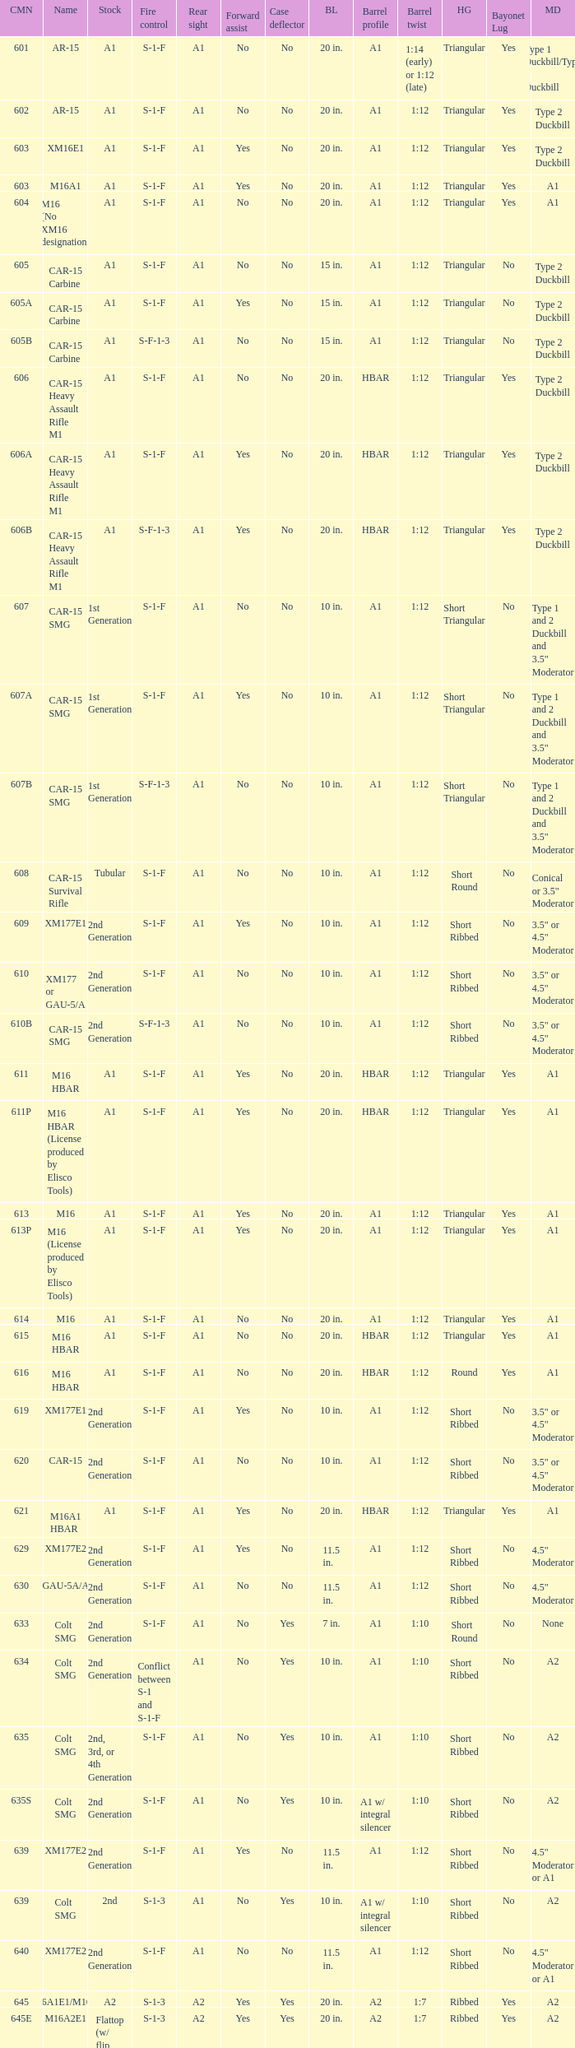What's the type of muzzle devices on the models with round hand guards? A1. Could you help me parse every detail presented in this table? {'header': ['CMN', 'Name', 'Stock', 'Fire control', 'Rear sight', 'Forward assist', 'Case deflector', 'BL', 'Barrel profile', 'Barrel twist', 'HG', 'Bayonet Lug', 'MD'], 'rows': [['601', 'AR-15', 'A1', 'S-1-F', 'A1', 'No', 'No', '20 in.', 'A1', '1:14 (early) or 1:12 (late)', 'Triangular', 'Yes', 'Type 1 Duckbill/Type 2 Duckbill'], ['602', 'AR-15', 'A1', 'S-1-F', 'A1', 'No', 'No', '20 in.', 'A1', '1:12', 'Triangular', 'Yes', 'Type 2 Duckbill'], ['603', 'XM16E1', 'A1', 'S-1-F', 'A1', 'Yes', 'No', '20 in.', 'A1', '1:12', 'Triangular', 'Yes', 'Type 2 Duckbill'], ['603', 'M16A1', 'A1', 'S-1-F', 'A1', 'Yes', 'No', '20 in.', 'A1', '1:12', 'Triangular', 'Yes', 'A1'], ['604', 'M16 (No XM16 designation)', 'A1', 'S-1-F', 'A1', 'No', 'No', '20 in.', 'A1', '1:12', 'Triangular', 'Yes', 'A1'], ['605', 'CAR-15 Carbine', 'A1', 'S-1-F', 'A1', 'No', 'No', '15 in.', 'A1', '1:12', 'Triangular', 'No', 'Type 2 Duckbill'], ['605A', 'CAR-15 Carbine', 'A1', 'S-1-F', 'A1', 'Yes', 'No', '15 in.', 'A1', '1:12', 'Triangular', 'No', 'Type 2 Duckbill'], ['605B', 'CAR-15 Carbine', 'A1', 'S-F-1-3', 'A1', 'No', 'No', '15 in.', 'A1', '1:12', 'Triangular', 'No', 'Type 2 Duckbill'], ['606', 'CAR-15 Heavy Assault Rifle M1', 'A1', 'S-1-F', 'A1', 'No', 'No', '20 in.', 'HBAR', '1:12', 'Triangular', 'Yes', 'Type 2 Duckbill'], ['606A', 'CAR-15 Heavy Assault Rifle M1', 'A1', 'S-1-F', 'A1', 'Yes', 'No', '20 in.', 'HBAR', '1:12', 'Triangular', 'Yes', 'Type 2 Duckbill'], ['606B', 'CAR-15 Heavy Assault Rifle M1', 'A1', 'S-F-1-3', 'A1', 'Yes', 'No', '20 in.', 'HBAR', '1:12', 'Triangular', 'Yes', 'Type 2 Duckbill'], ['607', 'CAR-15 SMG', '1st Generation', 'S-1-F', 'A1', 'No', 'No', '10 in.', 'A1', '1:12', 'Short Triangular', 'No', 'Type 1 and 2 Duckbill and 3.5" Moderator'], ['607A', 'CAR-15 SMG', '1st Generation', 'S-1-F', 'A1', 'Yes', 'No', '10 in.', 'A1', '1:12', 'Short Triangular', 'No', 'Type 1 and 2 Duckbill and 3.5" Moderator'], ['607B', 'CAR-15 SMG', '1st Generation', 'S-F-1-3', 'A1', 'No', 'No', '10 in.', 'A1', '1:12', 'Short Triangular', 'No', 'Type 1 and 2 Duckbill and 3.5" Moderator'], ['608', 'CAR-15 Survival Rifle', 'Tubular', 'S-1-F', 'A1', 'No', 'No', '10 in.', 'A1', '1:12', 'Short Round', 'No', 'Conical or 3.5" Moderator'], ['609', 'XM177E1', '2nd Generation', 'S-1-F', 'A1', 'Yes', 'No', '10 in.', 'A1', '1:12', 'Short Ribbed', 'No', '3.5" or 4.5" Moderator'], ['610', 'XM177 or GAU-5/A', '2nd Generation', 'S-1-F', 'A1', 'No', 'No', '10 in.', 'A1', '1:12', 'Short Ribbed', 'No', '3.5" or 4.5" Moderator'], ['610B', 'CAR-15 SMG', '2nd Generation', 'S-F-1-3', 'A1', 'No', 'No', '10 in.', 'A1', '1:12', 'Short Ribbed', 'No', '3.5" or 4.5" Moderator'], ['611', 'M16 HBAR', 'A1', 'S-1-F', 'A1', 'Yes', 'No', '20 in.', 'HBAR', '1:12', 'Triangular', 'Yes', 'A1'], ['611P', 'M16 HBAR (License produced by Elisco Tools)', 'A1', 'S-1-F', 'A1', 'Yes', 'No', '20 in.', 'HBAR', '1:12', 'Triangular', 'Yes', 'A1'], ['613', 'M16', 'A1', 'S-1-F', 'A1', 'Yes', 'No', '20 in.', 'A1', '1:12', 'Triangular', 'Yes', 'A1'], ['613P', 'M16 (License produced by Elisco Tools)', 'A1', 'S-1-F', 'A1', 'Yes', 'No', '20 in.', 'A1', '1:12', 'Triangular', 'Yes', 'A1'], ['614', 'M16', 'A1', 'S-1-F', 'A1', 'No', 'No', '20 in.', 'A1', '1:12', 'Triangular', 'Yes', 'A1'], ['615', 'M16 HBAR', 'A1', 'S-1-F', 'A1', 'No', 'No', '20 in.', 'HBAR', '1:12', 'Triangular', 'Yes', 'A1'], ['616', 'M16 HBAR', 'A1', 'S-1-F', 'A1', 'No', 'No', '20 in.', 'HBAR', '1:12', 'Round', 'Yes', 'A1'], ['619', 'XM177E1', '2nd Generation', 'S-1-F', 'A1', 'Yes', 'No', '10 in.', 'A1', '1:12', 'Short Ribbed', 'No', '3.5" or 4.5" Moderator'], ['620', 'CAR-15', '2nd Generation', 'S-1-F', 'A1', 'No', 'No', '10 in.', 'A1', '1:12', 'Short Ribbed', 'No', '3.5" or 4.5" Moderator'], ['621', 'M16A1 HBAR', 'A1', 'S-1-F', 'A1', 'Yes', 'No', '20 in.', 'HBAR', '1:12', 'Triangular', 'Yes', 'A1'], ['629', 'XM177E2', '2nd Generation', 'S-1-F', 'A1', 'Yes', 'No', '11.5 in.', 'A1', '1:12', 'Short Ribbed', 'No', '4.5" Moderator'], ['630', 'GAU-5A/A', '2nd Generation', 'S-1-F', 'A1', 'No', 'No', '11.5 in.', 'A1', '1:12', 'Short Ribbed', 'No', '4.5" Moderator'], ['633', 'Colt SMG', '2nd Generation', 'S-1-F', 'A1', 'No', 'Yes', '7 in.', 'A1', '1:10', 'Short Round', 'No', 'None'], ['634', 'Colt SMG', '2nd Generation', 'Conflict between S-1 and S-1-F', 'A1', 'No', 'Yes', '10 in.', 'A1', '1:10', 'Short Ribbed', 'No', 'A2'], ['635', 'Colt SMG', '2nd, 3rd, or 4th Generation', 'S-1-F', 'A1', 'No', 'Yes', '10 in.', 'A1', '1:10', 'Short Ribbed', 'No', 'A2'], ['635S', 'Colt SMG', '2nd Generation', 'S-1-F', 'A1', 'No', 'Yes', '10 in.', 'A1 w/ integral silencer', '1:10', 'Short Ribbed', 'No', 'A2'], ['639', 'XM177E2', '2nd Generation', 'S-1-F', 'A1', 'Yes', 'No', '11.5 in.', 'A1', '1:12', 'Short Ribbed', 'No', '4.5" Moderator or A1'], ['639', 'Colt SMG', '2nd', 'S-1-3', 'A1', 'No', 'Yes', '10 in.', 'A1 w/ integral silencer', '1:10', 'Short Ribbed', 'No', 'A2'], ['640', 'XM177E2', '2nd Generation', 'S-1-F', 'A1', 'No', 'No', '11.5 in.', 'A1', '1:12', 'Short Ribbed', 'No', '4.5" Moderator or A1'], ['645', 'M16A1E1/M16A2', 'A2', 'S-1-3', 'A2', 'Yes', 'Yes', '20 in.', 'A2', '1:7', 'Ribbed', 'Yes', 'A2'], ['645E', 'M16A2E1', 'Flattop (w/ flip down front sight)', 'S-1-3', 'A2', 'Yes', 'Yes', '20 in.', 'A2', '1:7', 'Ribbed', 'Yes', 'A2'], ['646', 'M16A2E3/M16A3', 'A2', 'S-1-F', 'A2', 'Yes', 'Yes', '20 in.', 'A2', '1:7', 'Ribbed', 'Yes', 'A2'], ['649', 'GAU-5A/A', '2nd Generation', 'S-1-F', 'A1', 'No', 'No', '11.5 in.', 'A1', '1:12', 'Short Ribbed', 'No', '4.5" Moderator'], ['650', 'M16A1 carbine', 'A1', 'S-1-F', 'A1', 'Yes', 'No', '14.5 in.', 'A1', '1:12', 'Short Ribbed', 'Yes', 'A1'], ['651', 'M16A1 carbine', 'A1', 'S-1-F', 'A1', 'Yes', 'No', '14.5 in.', 'A1', '1:12', 'Short Ribbed', 'Yes', 'A1'], ['652', 'M16A1 carbine', 'A1', 'S-1-F', 'A1', 'No', 'No', '14.5 in.', 'A1', '1:12', 'Short Ribbed', 'Yes', 'A1'], ['653', 'M16A1 carbine', '2nd Generation', 'S-1-F', 'A1', 'Yes', 'No', '14.5 in.', 'A1', '1:12', 'Short Ribbed', 'Yes', 'A1'], ['653P', 'M16A1 carbine (License produced by Elisco Tools)', '2nd Generation', 'S-1-F', 'A1', 'Yes', 'No', '14.5 in.', 'A1', '1:12', 'Short Ribbed', 'Yes', 'A1'], ['654', 'M16A1 carbine', '2nd Generation', 'S-1-F', 'A1', 'No', 'No', '14.5 in.', 'A1', '1:12', 'Short Ribbed', 'Yes', 'A1'], ['656', 'M16A1 Special Low Profile', 'A1', 'S-1-F', 'Flattop', 'Yes', 'No', '20 in.', 'HBAR', '1:12', 'Triangular', 'Yes', 'A1'], ['701', 'M16A2', 'A2', 'S-1-F', 'A2', 'Yes', 'Yes', '20 in.', 'A2', '1:7', 'Ribbed', 'Yes', 'A2'], ['702', 'M16A2', 'A2', 'S-1-3', 'A2', 'Yes', 'Yes', '20 in.', 'A2', '1:7', 'Ribbed', 'Yes', 'A2'], ['703', 'M16A2', 'A2', 'S-1-F', 'A2', 'Yes', 'Yes', '20 in.', 'A1', '1:7', 'Ribbed', 'Yes', 'A2'], ['705', 'M16A2', 'A2', 'S-1-3', 'A2', 'Yes', 'Yes', '20 in.', 'A2', '1:7', 'Ribbed', 'Yes', 'A2'], ['707', 'M16A2', 'A2', 'S-1-3', 'A2', 'Yes', 'Yes', '20 in.', 'A1', '1:7', 'Ribbed', 'Yes', 'A2'], ['711', 'M16A2', 'A2', 'S-1-F', 'A1', 'Yes', 'No and Yes', '20 in.', 'A1', '1:7', 'Ribbed', 'Yes', 'A2'], ['713', 'M16A2', 'A2', 'S-1-3', 'A2', 'Yes', 'Yes', '20 in.', 'A2', '1:7', 'Ribbed', 'Yes', 'A2'], ['719', 'M16A2', 'A2', 'S-1-3', 'A2', 'Yes', 'Yes', '20 in.', 'A1', '1:7', 'Ribbed', 'Yes', 'A2'], ['720', 'XM4 Carbine', '3rd Generation', 'S-1-3', 'A2', 'Yes', 'Yes', '14.5 in.', 'M4', '1:7', 'Short Ribbed', 'Yes', 'A2'], ['723', 'M16A2 carbine', '3rd Generation', 'S-1-F', 'A1', 'Yes', 'Yes', '14.5 in.', 'A1', '1:7', 'Short Ribbed', 'Yes', 'A1'], ['725A', 'M16A2 carbine', '3rd Generation', 'S-1-F', 'A1', 'Yes', 'Yes', '14.5 in.', 'A1', '1:7', 'Short Ribbed', 'Yes', 'A2'], ['725B', 'M16A2 carbine', '3rd Generation', 'S-1-F', 'A1', 'Yes', 'Yes', '14.5 in.', 'A2', '1:7', 'Short Ribbed', 'Yes', 'A2'], ['726', 'M16A2 carbine', '3rd Generation', 'S-1-F', 'A1', 'Yes', 'Yes', '14.5 in.', 'A1', '1:7', 'Short Ribbed', 'Yes', 'A1'], ['727', 'M16A2 carbine', '3rd Generation', 'S-1-F', 'A2', 'Yes', 'Yes', '14.5 in.', 'M4', '1:7', 'Short Ribbed', 'Yes', 'A2'], ['728', 'M16A2 carbine', '3rd Generation', 'S-1-F', 'A2', 'Yes', 'Yes', '14.5 in.', 'M4', '1:7', 'Short Ribbed', 'Yes', 'A2'], ['733', 'M16A2 Commando / M4 Commando', '3rd or 4th Generation', 'S-1-F', 'A1 or A2', 'Yes', 'Yes or No', '11.5 in.', 'A1 or A2', '1:7', 'Short Ribbed', 'No', 'A1 or A2'], ['733A', 'M16A2 Commando / M4 Commando', '3rd or 4th Generation', 'S-1-3', 'A1 or A2', 'Yes', 'Yes or No', '11.5 in.', 'A1 or A2', '1:7', 'Short Ribbed', 'No', 'A1 or A2'], ['734', 'M16A2 Commando', '3rd Generation', 'S-1-F', 'A1 or A2', 'Yes', 'Yes or No', '11.5 in.', 'A1 or A2', '1:7', 'Short Ribbed', 'No', 'A1 or A2'], ['734A', 'M16A2 Commando', '3rd Generation', 'S-1-3', 'A1 or A2', 'Yes', 'Yes or No', '11.5 in.', 'A1 or A2', '1:7', 'Short Ribbed', 'No', 'A1 or A2'], ['735', 'M16A2 Commando / M4 Commando', '3rd or 4th Generation', 'S-1-3', 'A1 or A2', 'Yes', 'Yes or No', '11.5 in.', 'A1 or A2', '1:7', 'Short Ribbed', 'No', 'A1 or A2'], ['737', 'M16A2', 'A2', 'S-1-3', 'A2', 'Yes', 'Yes', '20 in.', 'HBAR', '1:7', 'Ribbed', 'Yes', 'A2'], ['738', 'M4 Commando Enhanced', '4th Generation', 'S-1-3-F', 'A2', 'Yes', 'Yes', '11.5 in.', 'A2', '1:7', 'Short Ribbed', 'No', 'A1 or A2'], ['741', 'M16A2', 'A2', 'S-1-F', 'A2', 'Yes', 'Yes', '20 in.', 'HBAR', '1:7', 'Ribbed', 'Yes', 'A2'], ['742', 'M16A2 (Standard w/ bipod)', 'A2', 'S-1-F', 'A2', 'Yes', 'Yes', '20 in.', 'HBAR', '1:7', 'Ribbed', 'Yes', 'A2'], ['745', 'M16A2 (Standard w/ bipod)', 'A2', 'S-1-3', 'A2', 'Yes', 'Yes', '20 in.', 'HBAR', '1:7', 'Ribbed', 'Yes', 'A2'], ['746', 'M16A2 (Standard w/ bipod)', 'A2', 'S-1-3', 'A2', 'Yes', 'Yes', '20 in.', 'HBAR', '1:7', 'Ribbed', 'Yes', 'A2'], ['750', 'LMG (Colt/ Diemaco project)', 'A2', 'S-F', 'A2', 'Yes', 'Yes', '20 in.', 'HBAR', '1:7', 'Square LMG', 'Yes', 'A2'], ['777', 'M4 Carbine', '4th Generation', 'S-1-3', 'A2', 'Yes', 'Yes', '14.5 in.', 'M4', '1:7', 'M4', 'Yes', 'A2'], ['778', 'M4 Carbine Enhanced', '4th Generation', 'S-1-3-F', 'A2', 'Yes', 'Yes', '14.5 in.', 'M4', '1:7', 'M4', 'Yes', 'A2'], ['779', 'M4 Carbine', '4th Generation', 'S-1-F', 'A2', 'Yes', 'Yes', '14.5 in.', 'M4', '1:7', 'M4', 'Yes', 'A2'], ['901', 'M16A3', 'A2', 'S-1-F', 'Flattop', 'Yes', 'Yes', '20 in.', 'A2', '1:7', 'Ribbed', 'Yes', 'A2'], ['905', 'M16A4', 'A2', 'S-1-3', 'Flattop', 'Yes', 'Yes', '20 in.', 'A2', '1:7', 'Ribbed', 'Yes', 'A2'], ['920', 'M4 Carbine', '3rd and 4th Generation', 'S-1-3', 'Flattop', 'Yes', 'Yes', '14.5 in.', 'M4', '1:7', 'M4', 'Yes', 'A2'], ['921', 'M4E1/A1 Carbine', '4th Generation', 'S-1-F', 'Flattop', 'Yes', 'Yes', '14.5 in.', 'M4', '1:7', 'M4', 'Yes', 'A2'], ['921HB', 'M4A1 Carbine', '4th Generation', 'S-1-F', 'Flattop', 'Yes', 'Yes', '14.5 in.', 'M4 HBAR', '1:7', 'M4', 'Yes', 'A2'], ['925', 'M4E2 Carbine', '3rd or 4th Generation', 'S-1-3', 'Flattop', 'Yes', 'Yes', '14.5 in.', 'M4', '1:7', 'M4', 'Yes', 'A2'], ['927', 'M4 Carbine', '4th Generation', 'S-1-F', 'Flattop', 'Yes', 'Yes', '14.5 in.', 'M4', '1:7', 'M4', 'Yes', 'A2'], ['933', 'M4 Commando', '4th Generation', 'S-1-F', 'Flattop', 'Yes', 'Yes', '11.5 in.', 'A1 or A2', '1:7', 'Short Ribbed', 'No', 'A2'], ['935', 'M4 Commando', '4th Generation', 'S-1-3', 'Flattop', 'Yes', 'Yes', '11.5 in.', 'A1 or A2', '1:7', 'Short Ribbed', 'No', 'A2'], ['938', 'M4 Commando Enhanced', '4th Generation', 'S-1-3-F', 'Flattop', 'Yes', 'Yes', '11.5 in.', 'A2', '1:7', 'M4', 'No', 'A2'], ['977', 'M4 Carbine', '4th Generation', 'S-1-3', 'Flattop', 'Yes', 'Yes', '14.5 in.', 'M4', '1:7', 'M4', 'Yes', 'A2'], ['941', 'M16A3', 'A2', 'S-1-F', 'Flattop', 'Yes', 'Yes', '20 in.', 'HBAR', '1:7', 'Ribbed', 'Yes', 'A2'], ['942', 'M16A3 (Standard w/ bipod)', 'A2', 'S-1-F', 'Flattop', 'Yes', 'Yes', '20 in.', 'HBAR', '1:7', 'Ribbed', 'Yes', 'A2'], ['945', 'M16A2E4/M16A4', 'A2', 'S-1-3', 'Flattop', 'Yes', 'Yes', '20 in.', 'A2', '1:7', 'Ribbed', 'Yes', 'A2'], ['950', 'LMG (Colt/ Diemaco project)', 'A2', 'S-F', 'Flattop', 'Yes', 'Yes', '20 in.', 'HBAR', '1:7', 'Square LMG', 'Yes', 'A2'], ['"977"', 'M4 Carbine', '4th Generation', 'S-1-3', 'Flattop', 'Yes', 'Yes', '14.5 in.', 'M4', '1:7', 'M4', 'Yes', 'A2'], ['978', 'M4 Carbine Enhanced', '4th Generation', 'S-1-3-F', 'Flattop', 'Yes', 'Yes', '14.5 in.', 'M4', '1:7', 'M4', 'Yes', 'A2'], ['979', 'M4A1 Carbine', '4th Generation', 'S-1-F', 'Flattop', 'Yes', 'Yes', '14.5 in.', 'M4', '1:7', 'M4', 'Yes', 'A2']]} 